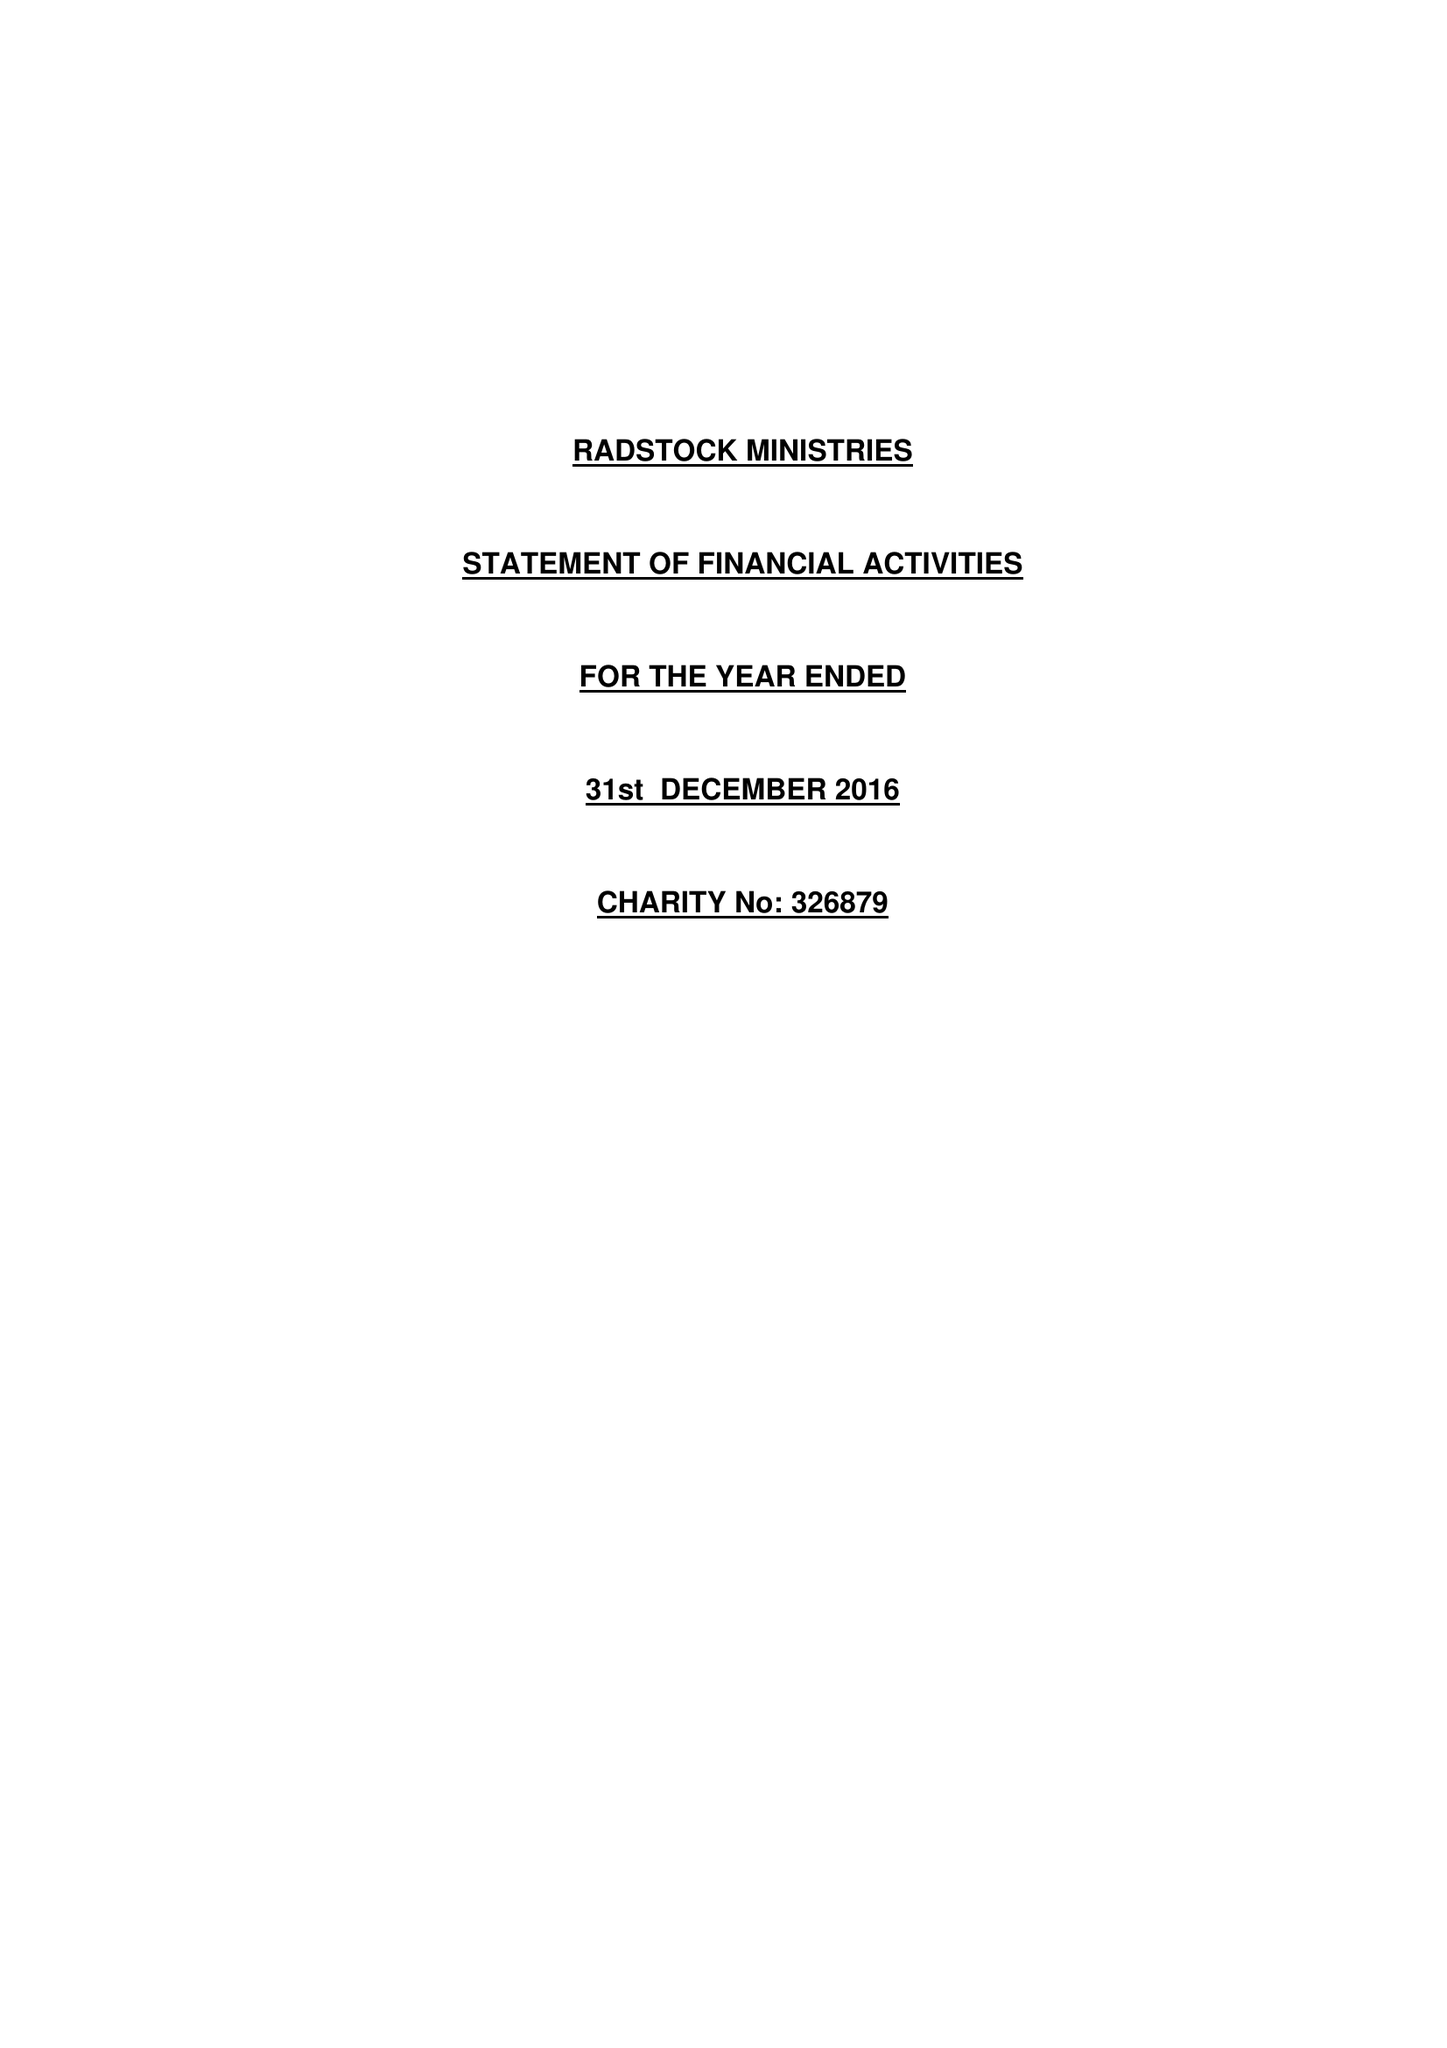What is the value for the income_annually_in_british_pounds?
Answer the question using a single word or phrase. 174836.00 